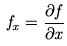Convert formula to latex. <formula><loc_0><loc_0><loc_500><loc_500>f _ { x } = \frac { \partial f } { \partial x }</formula> 